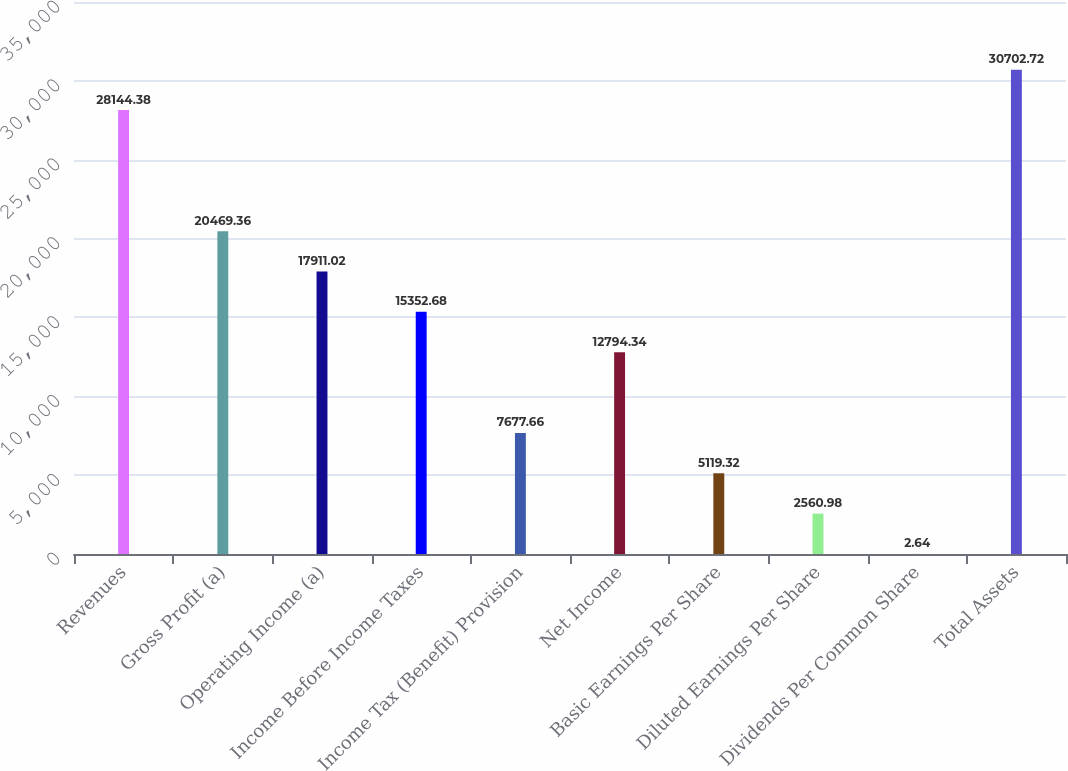Convert chart. <chart><loc_0><loc_0><loc_500><loc_500><bar_chart><fcel>Revenues<fcel>Gross Profit (a)<fcel>Operating Income (a)<fcel>Income Before Income Taxes<fcel>Income Tax (Benefit) Provision<fcel>Net Income<fcel>Basic Earnings Per Share<fcel>Diluted Earnings Per Share<fcel>Dividends Per Common Share<fcel>Total Assets<nl><fcel>28144.4<fcel>20469.4<fcel>17911<fcel>15352.7<fcel>7677.66<fcel>12794.3<fcel>5119.32<fcel>2560.98<fcel>2.64<fcel>30702.7<nl></chart> 